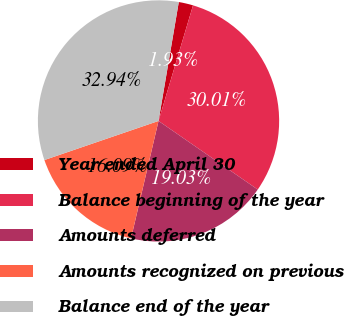Convert chart to OTSL. <chart><loc_0><loc_0><loc_500><loc_500><pie_chart><fcel>Year ended April 30<fcel>Balance beginning of the year<fcel>Amounts deferred<fcel>Amounts recognized on previous<fcel>Balance end of the year<nl><fcel>1.93%<fcel>30.01%<fcel>19.03%<fcel>16.09%<fcel>32.94%<nl></chart> 